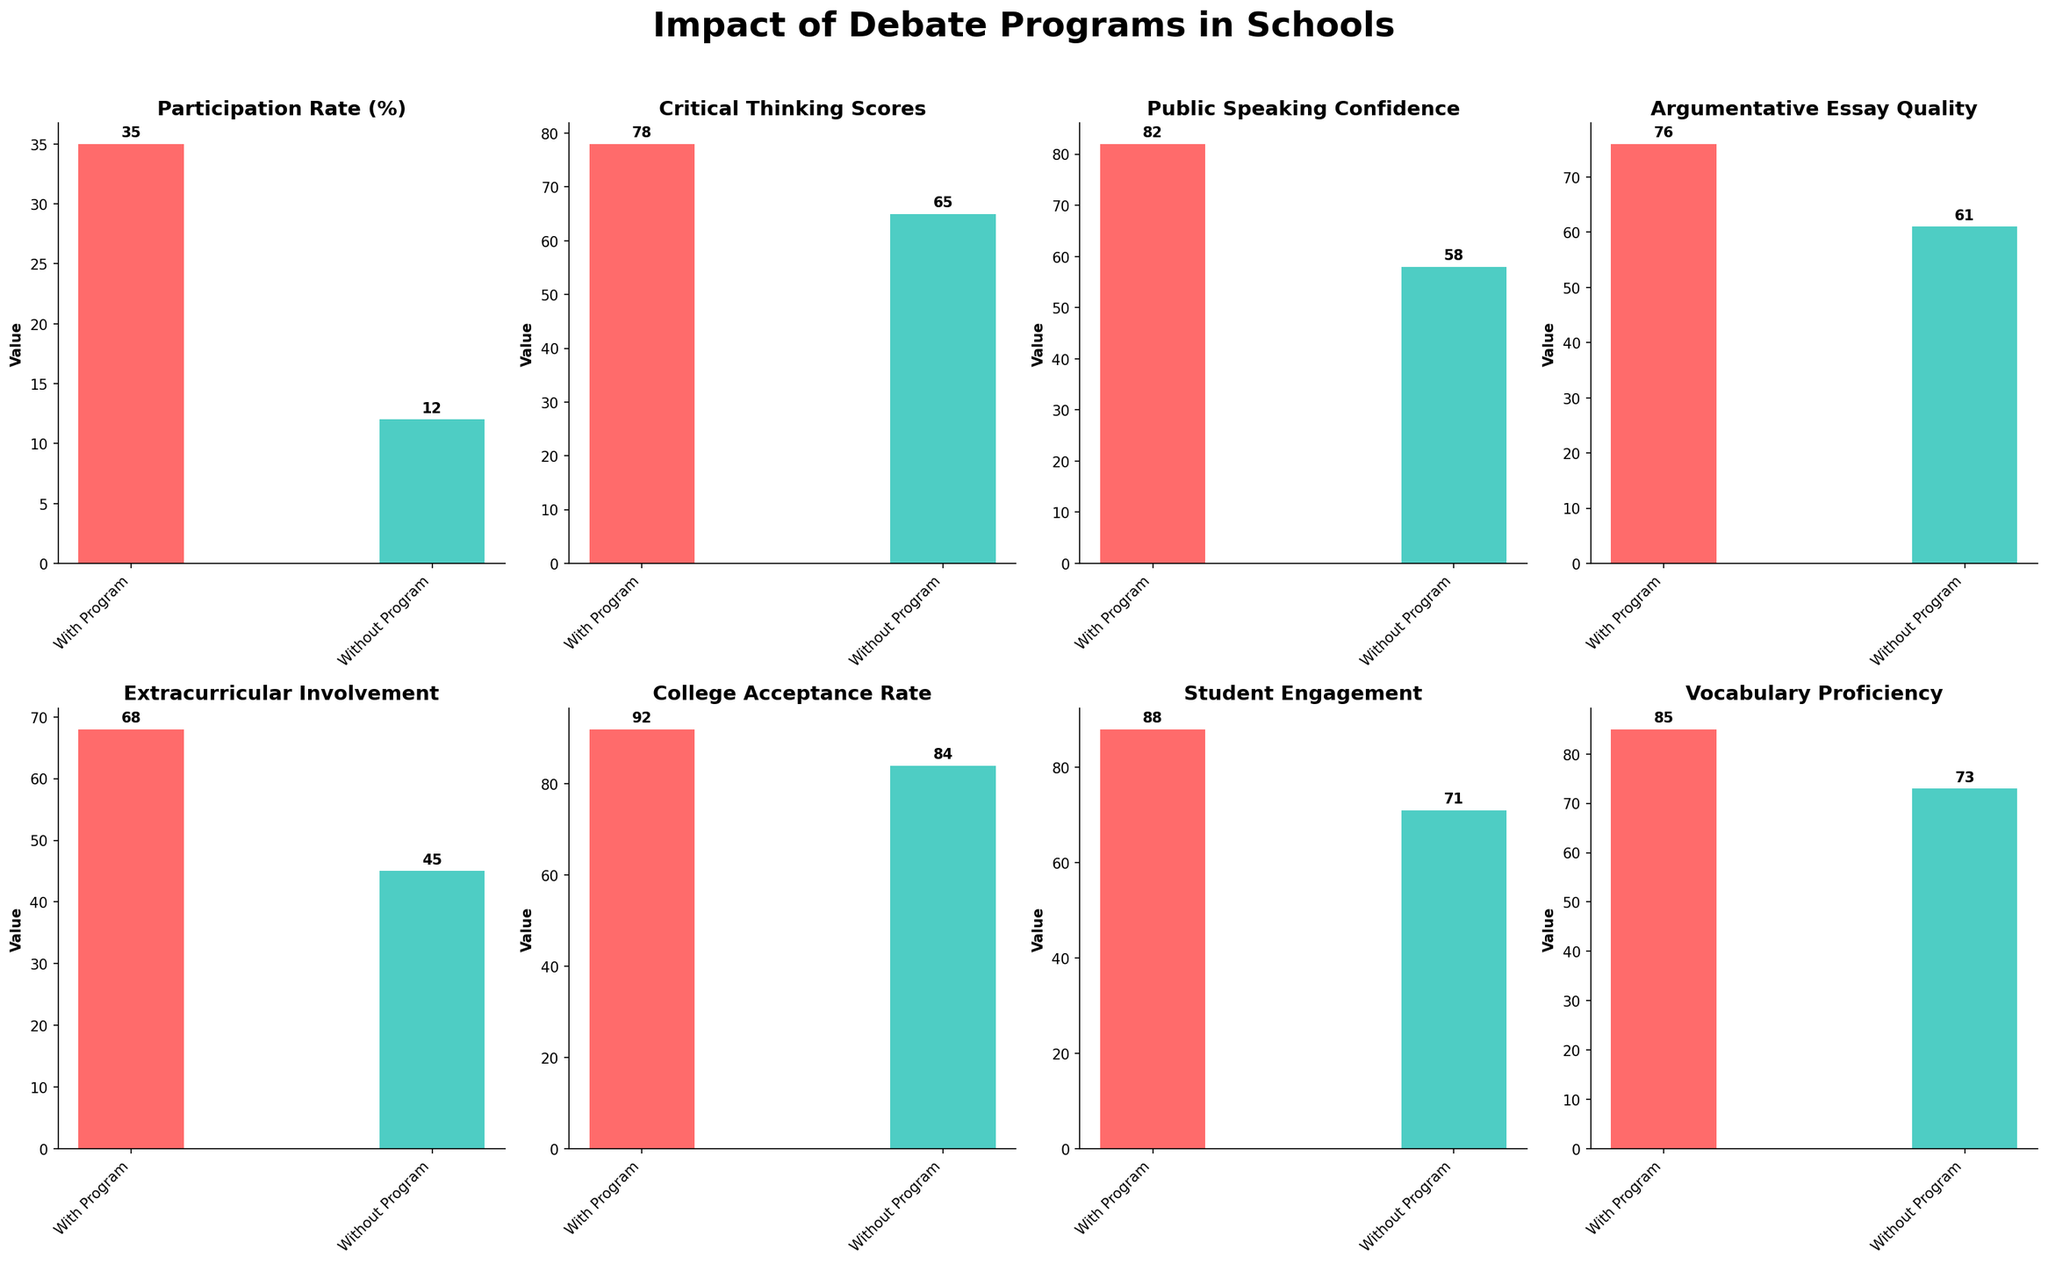What is the title of the figure? The title of the figure is located at the top center of the figure. You can read it directly from the figure.
Answer: Impact of Debate Programs in Schools Which category shows the biggest difference in participation rates between schools with and without debate programs? Look at the subplot for 'Participation Rate (%)' and compare the heights of the bars.
Answer: Participation Rate (%) How much higher is the Public Speaking Confidence score in schools with debate programs compared to those without? Find the difference between the 'With Program' and 'Without Program' values in the Public Speaking Confidence subplot, 82 - 58.
Answer: 24 What is the color of the bars for 'Without Debate Program'? Identify the color of the bars labeled 'Without Program' in any subplot.
Answer: Turquoise Which category has the smallest difference between schools with and without debate programs? Compare the differences in height for each pair of bars across all subplots and identify the smallest one.
Answer: College Acceptance Rate What's the average score for Vocabulary Proficiency in both school types? Add the scores for 'With Program' and 'Without Program' in the Vocabulary Proficiency subplot and divide by 2: (85+73)/2.
Answer: 79 Is Student Engagement higher in schools with debate programs or without? Compare the heights of the bars in the Student Engagement subplot.
Answer: With debate programs How much greater is the Extracurricular Involvement in schools with debate programs compared to schools without? Subtract the score for 'Without Program' from 'With Program' in the Extracurricular Involvement subplot, 68 - 45.
Answer: 23 Which category has the highest value for schools with debate programs? Look at all the 'With Program' bars and identify the tallest one.
Answer: College Acceptance Rate 